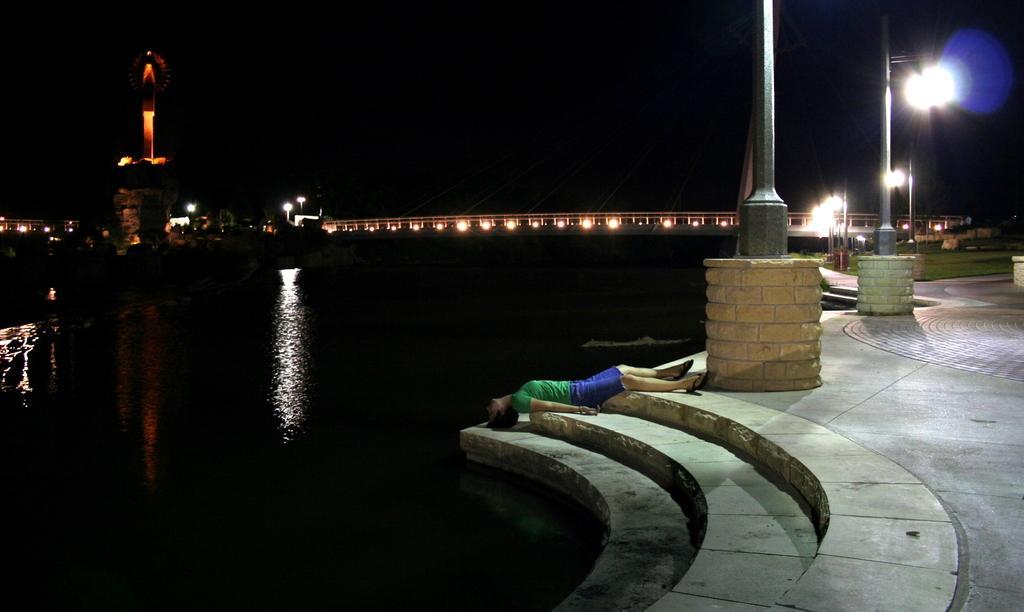Describe this image in one or two sentences. In this image we can see a lake, pavement, stairs and poles. We can see a man is lying on the stairs. In the background, we can see lights, a bridge and a structure. 